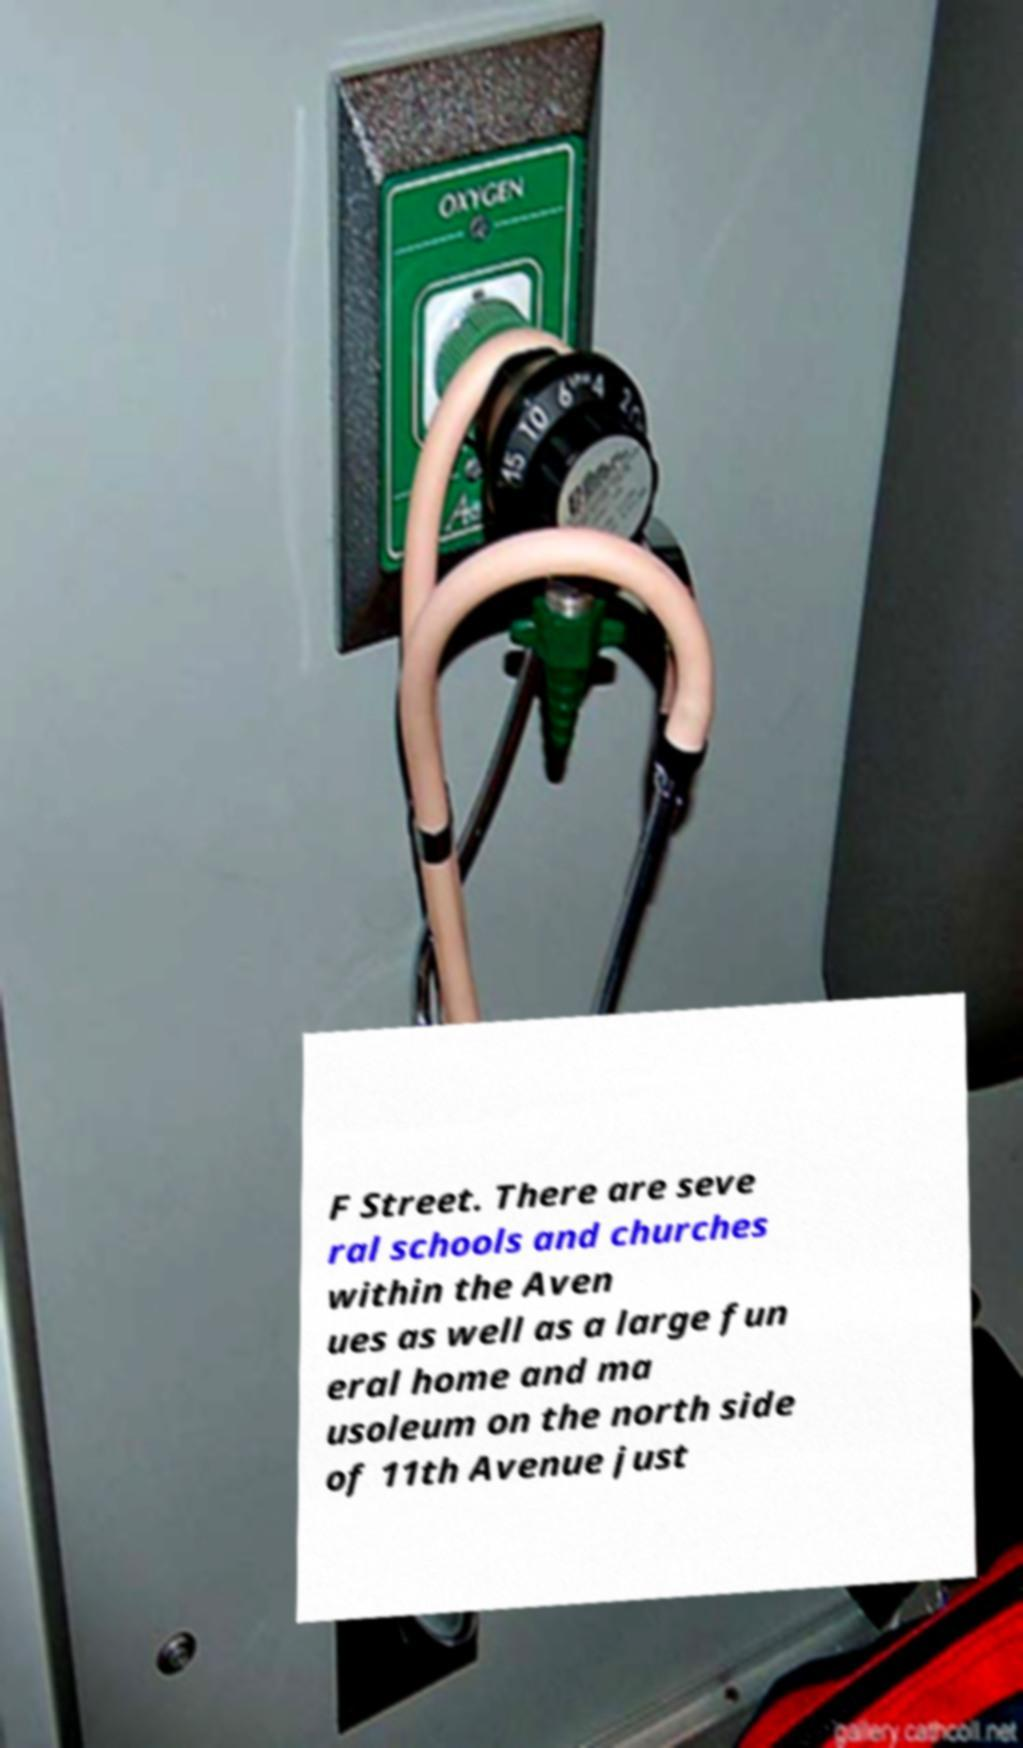Please identify and transcribe the text found in this image. F Street. There are seve ral schools and churches within the Aven ues as well as a large fun eral home and ma usoleum on the north side of 11th Avenue just 